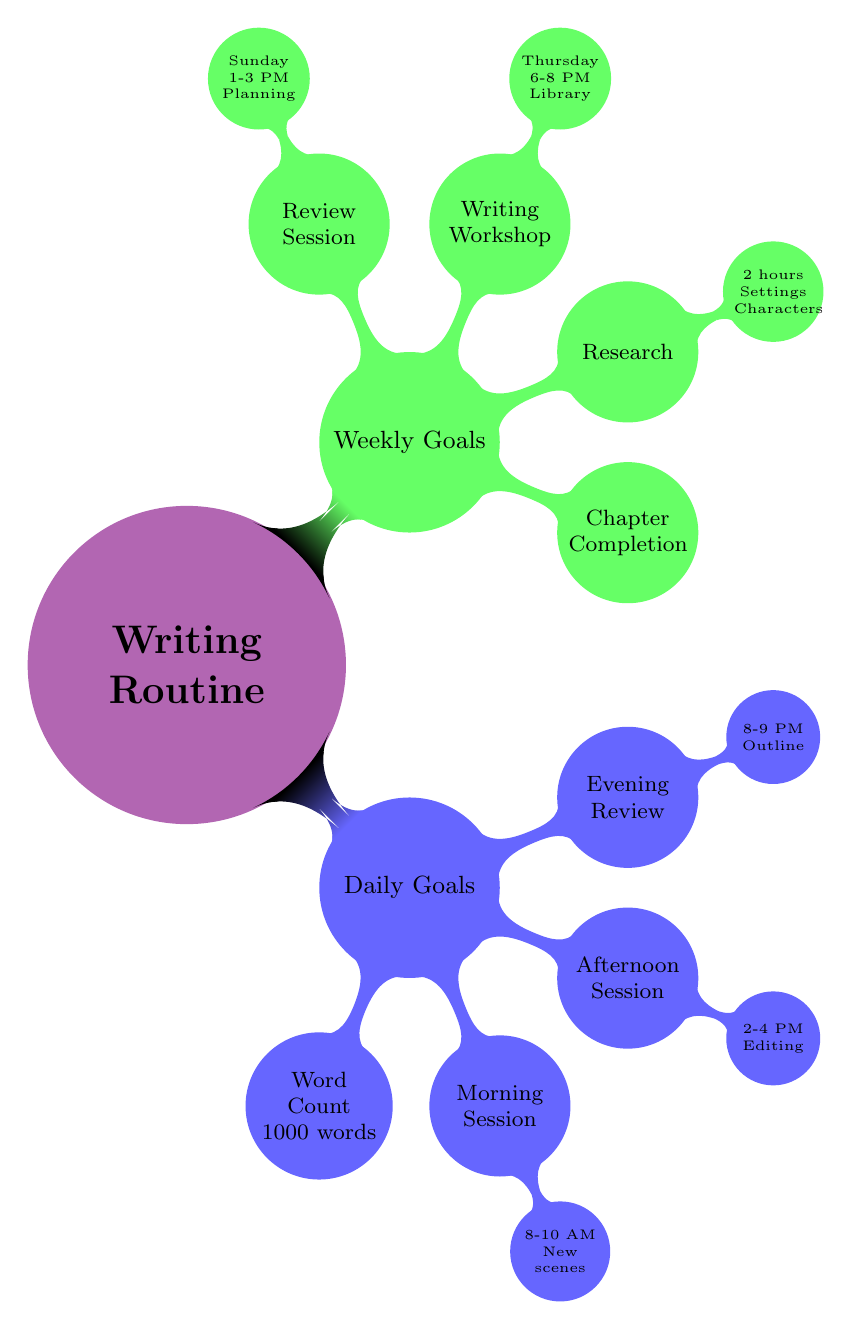What is the daily word count goal? The diagram directly indicates that the daily word count goal is specified under "Daily Goals" as "1000 words."
Answer: 1000 words What time does the morning writing session start? The start time for the morning writing session is shown in the diagram under "Morning Session," which states it begins at "8:00 AM."
Answer: 8:00 AM How many hours are allocated for research each week? The diagram specifically mentions under "Research" that two hours are dedicated to this activity each week.
Answer: Two hours On which day does the writing workshop occur? The "Writing Workshop" section of the diagram identifies "Thursday" as the designated day for this event.
Answer: Thursday What is the focus of the evening review session? The "Evening Review" node in the diagram details that the focus is on "Outline next day's writing," providing clarity on the task for that time period.
Answer: Outline next day's writing How many sessions are there in a day for writing activities? By analyzing "Daily Goals," we see that there are three distinct sessions mentioned: the morning session, the afternoon session, and the evening review, leading to a total of three.
Answer: Three What is the primary focus of the weekly review session? The diagram outlines that the focus for the "Review Session" on Sunday is "Goal assessment and planning," encompassing the overall purpose of that time.
Answer: Goal assessment and planning Which two components make up the afternoon writing session? The "Afternoon Session" under "Daily Goals" labeled items include the time slot "2-4 PM" and the focus area of "Editing and revisions," which together summarize the session's structure.
Answer: 2-4 PM, Editing and revisions How many goals are listed under weekly goals? By counting the nodes listed under "Weekly Goals" in the diagram, we find there are four distinct goals: "Chapter Completion," "Research," "Writing Workshop," and "Review Session."
Answer: Four 